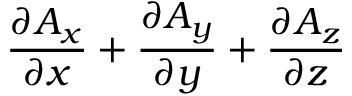Convert formula to latex. <formula><loc_0><loc_0><loc_500><loc_500>{ \frac { \partial A _ { x } } { \partial x } } + { \frac { \partial A _ { y } } { \partial y } } + { \frac { \partial A _ { z } } { \partial z } }</formula> 